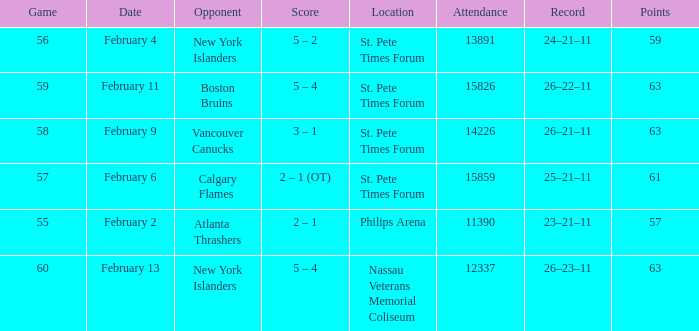What scores happened on February 9? 3 – 1. 